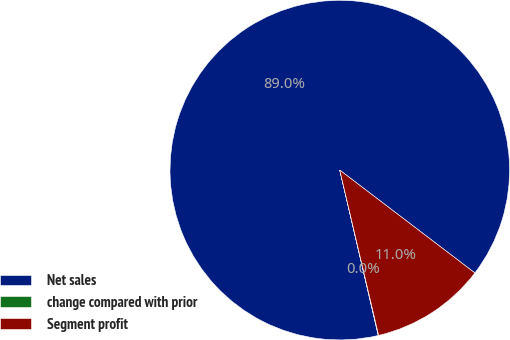Convert chart to OTSL. <chart><loc_0><loc_0><loc_500><loc_500><pie_chart><fcel>Net sales<fcel>change compared with prior<fcel>Segment profit<nl><fcel>88.99%<fcel>0.04%<fcel>10.97%<nl></chart> 